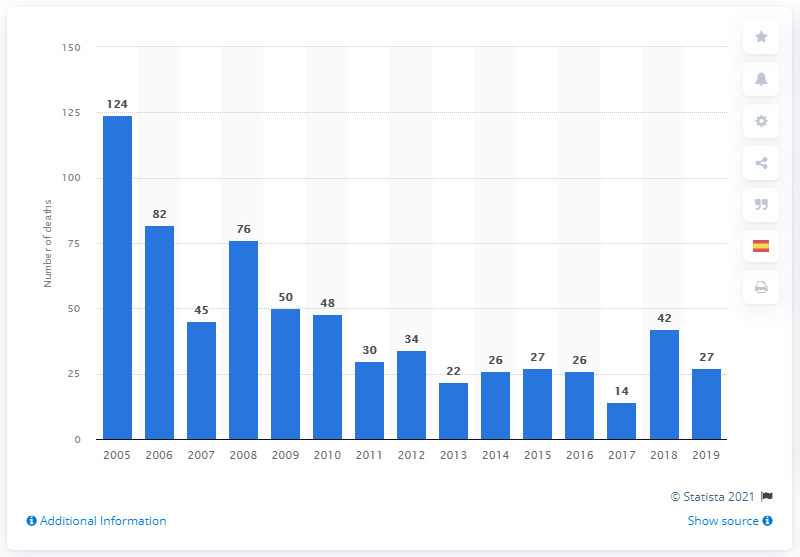Identify some key points in this picture. In 2019, 42 people lost their lives as a result of drug use disorders. 